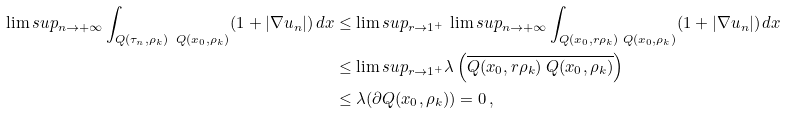<formula> <loc_0><loc_0><loc_500><loc_500>\lim s u p _ { n \to + \infty } \int _ { Q ( \tau _ { n } , \rho _ { k } ) \ Q ( x _ { 0 } , \rho _ { k } ) } ( 1 + | \nabla u _ { n } | ) \, d x & \leq \lim s u p _ { r \to 1 ^ { + } } \, \lim s u p _ { n \to + \infty } \int _ { Q ( x _ { 0 } , r \rho _ { k } ) \ Q ( x _ { 0 } , \rho _ { k } ) } ( 1 + | \nabla u _ { n } | ) \, d x \\ & \leq \lim s u p _ { r \to 1 ^ { + } } \lambda \left ( \overline { Q ( x _ { 0 } , r \rho _ { k } ) \ Q ( x _ { 0 } , \rho _ { k } ) } \right ) \\ & \leq \lambda ( \partial Q ( x _ { 0 } , \rho _ { k } ) ) = 0 \, ,</formula> 